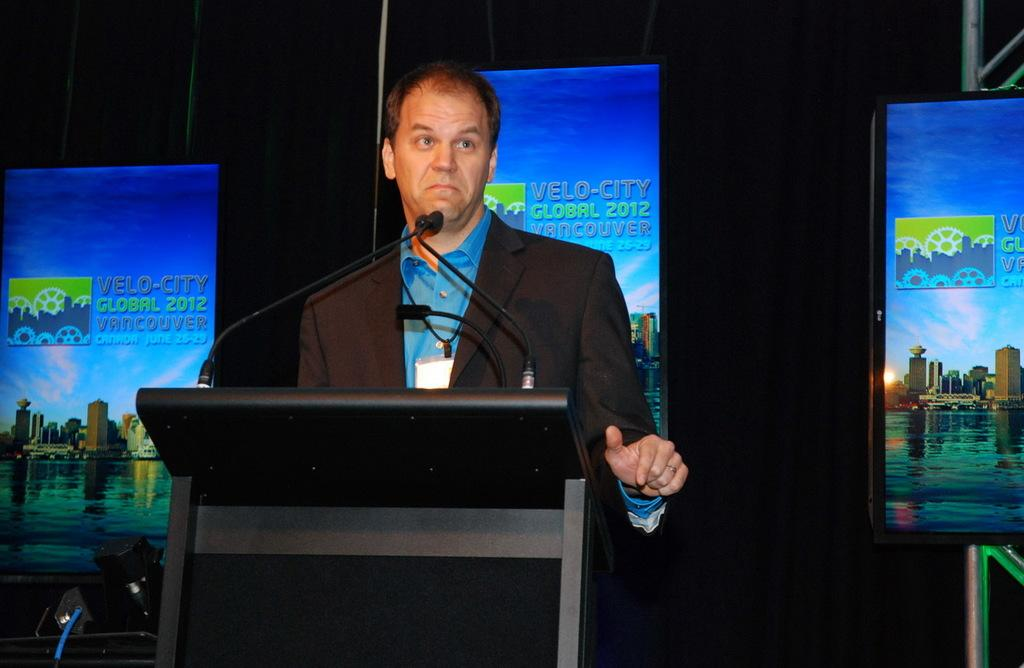Provide a one-sentence caption for the provided image. A speaker presents at the Velo-City Global 2012 Vancouver event. 